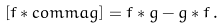Convert formula to latex. <formula><loc_0><loc_0><loc_500><loc_500>[ f \ast c o m m a g ] = f \ast g - g \ast f \, .</formula> 